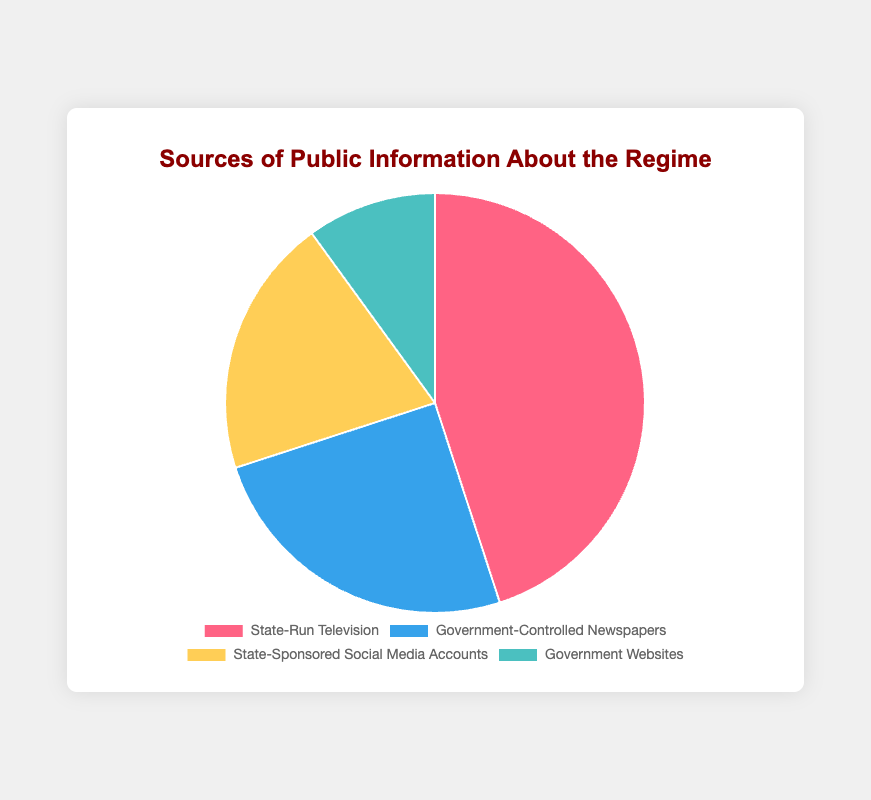Which information source has the largest percentage? By examining the chart, we can identify that the segment with the largest area or proportion corresponds to "State-Run Television," indicating it has the highest percentage of 45%.
Answer: State-Run Television What is the combined percentage of Government-Controlled Newspapers and Government Websites? We sum the percentages for Government-Controlled Newspapers (25%) and Government Websites (10%). So, 25 + 10 = 35%.
Answer: 35% By how much is the percentage of State-Sponsored Social Media Accounts less than State-Run Television? We subtract the percentage of State-Sponsored Social Media Accounts (20%) from State-Run Television (45%). So, 45 - 20 = 25%.
Answer: 25% Which sources together make up more than half of the total percentage? Checking the individual percentages, we see that State-Run Television (45%) and Government-Controlled Newspapers (25%) together sum up to 45 + 25 = 70%, which is more than 50%.
Answer: State-Run Television and Government-Controlled Newspapers What percentage is represented by the smallest information source? The chart shows the smallest segment corresponds to Government Websites, which represents 10%.
Answer: 10% Is the combined percentage of Government Websites and State-Sponsored Social Media Accounts greater than State-Run Television? We sum the percentages for Government Websites (10%) and State-Sponsored Social Media Accounts (20%) to get 10 + 20 = 30%, then compare it to 45% for State-Run Television. Since 30% is less than 45%, the answer is no.
Answer: No What is the average percentage of all the sources excluding the largest one? First, sum the percentages of all sources excluding State-Run Television: 25% (Government-Controlled Newspapers) + 20% (State-Sponsored Social Media Accounts) + 10% (Government Websites) = 55%. There are 3 sources, so the average is 55% / 3 = 18.33%.
Answer: 18.33% Which information source has the segment colored blue? From the chart, the dataset defines Government-Controlled Newspapers as the segment colored blue.
Answer: Government-Controlled Newspapers 